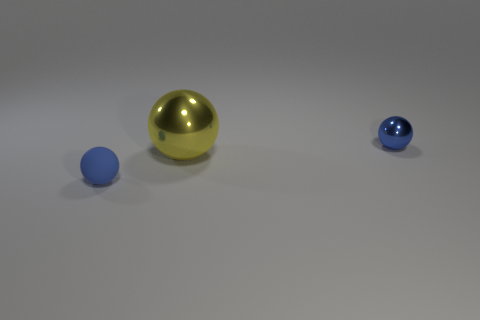What number of other things are there of the same material as the large object
Keep it short and to the point. 1. The matte thing left of the blue object behind the matte ball is what color?
Offer a terse response. Blue. Do the small metal thing that is behind the small rubber thing and the big ball have the same color?
Provide a short and direct response. No. Do the blue metal sphere and the rubber object have the same size?
Give a very brief answer. Yes. There is a metal thing that is the same size as the blue rubber ball; what shape is it?
Your response must be concise. Sphere. Do the blue ball on the left side of the blue metallic object and the tiny blue metallic thing have the same size?
Ensure brevity in your answer.  Yes. There is another thing that is the same size as the rubber thing; what is its material?
Provide a succinct answer. Metal. There is a yellow object that is in front of the blue thing that is behind the blue matte sphere; are there any spheres that are on the left side of it?
Give a very brief answer. Yes. Does the tiny ball that is on the right side of the small rubber ball have the same color as the object that is on the left side of the large metallic object?
Your response must be concise. Yes. Is there a small red rubber thing?
Offer a terse response. No. 